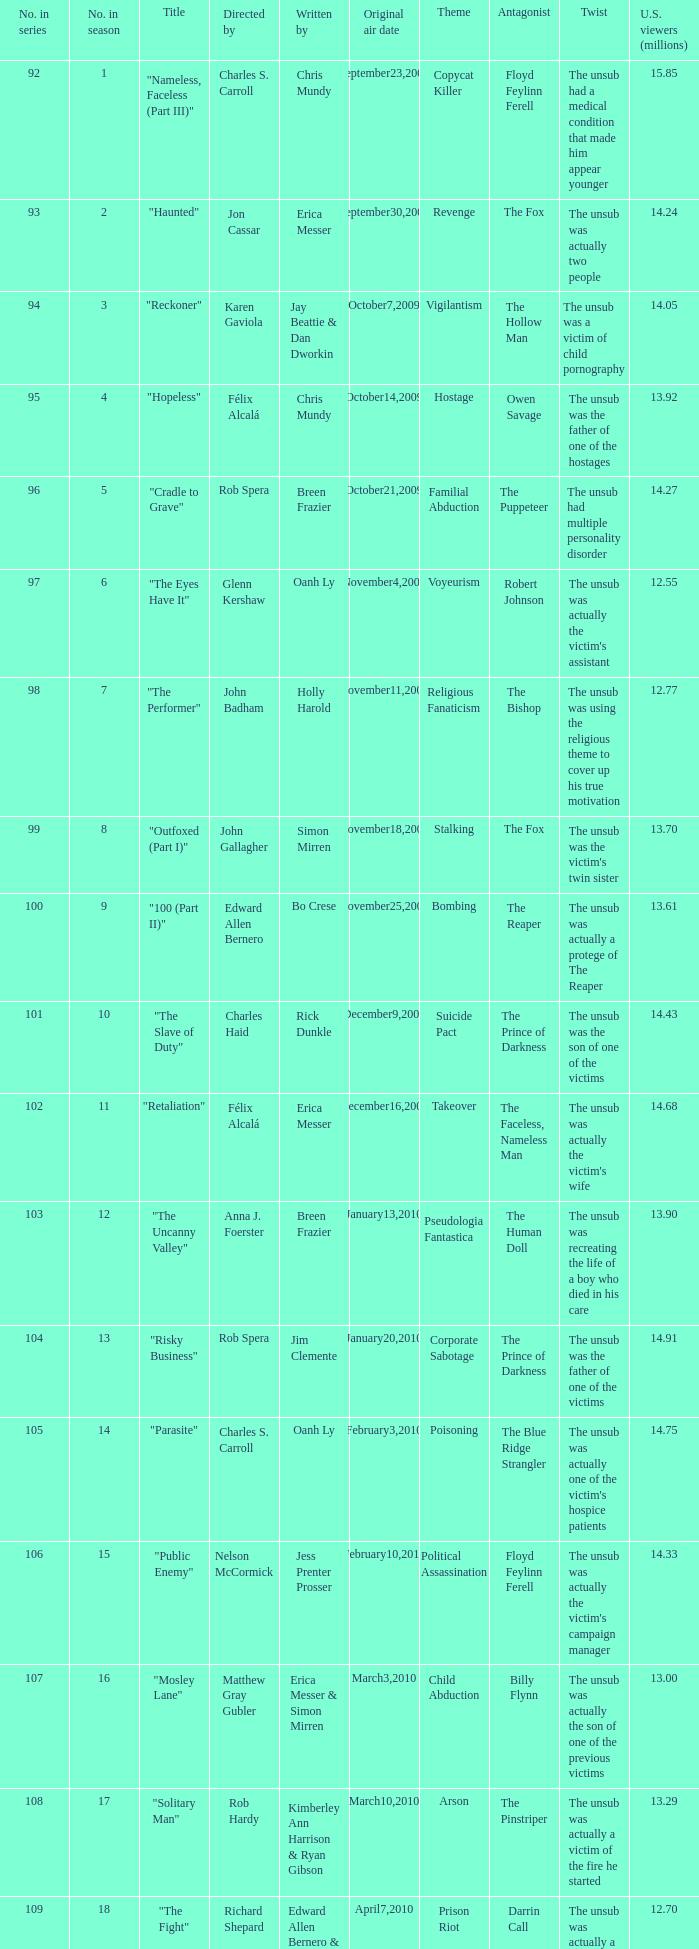What number(s) in the series was written by bo crese? 100.0. 